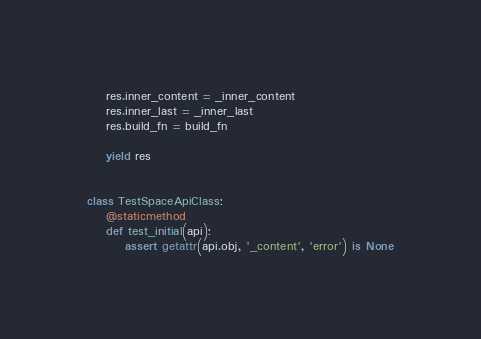<code> <loc_0><loc_0><loc_500><loc_500><_Python_>    res.inner_content = _inner_content
    res.inner_last = _inner_last
    res.build_fn = build_fn

    yield res


class TestSpaceApiClass:
    @staticmethod
    def test_initial(api):
        assert getattr(api.obj, '_content', 'error') is None</code> 